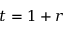Convert formula to latex. <formula><loc_0><loc_0><loc_500><loc_500>t = 1 + r</formula> 